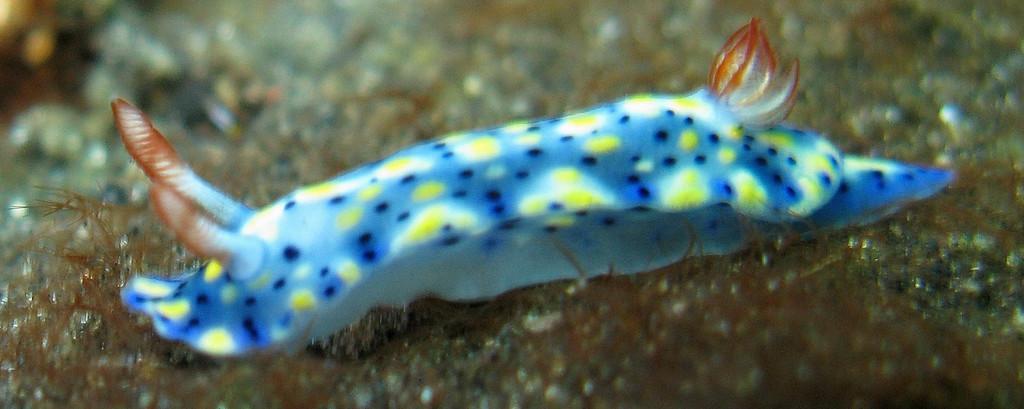In one or two sentences, can you explain what this image depicts? In this image I can see the aquatic animal in blue, white, yellow and brown color. Background is blurred. 